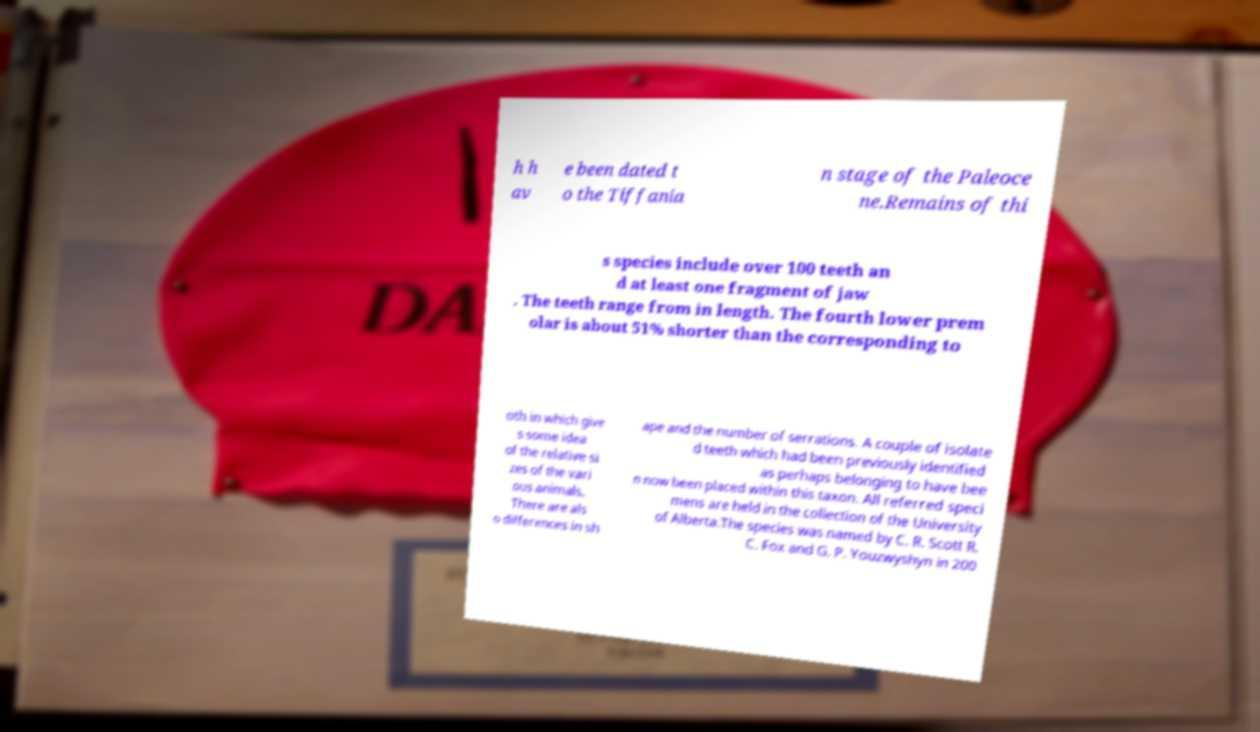There's text embedded in this image that I need extracted. Can you transcribe it verbatim? h h av e been dated t o the Tiffania n stage of the Paleoce ne.Remains of thi s species include over 100 teeth an d at least one fragment of jaw . The teeth range from in length. The fourth lower prem olar is about 51% shorter than the corresponding to oth in which give s some idea of the relative si zes of the vari ous animals. There are als o differences in sh ape and the number of serrations. A couple of isolate d teeth which had been previously identified as perhaps belonging to have bee n now been placed within this taxon. All referred speci mens are held in the collection of the University of Alberta.The species was named by C. R. Scott R. C. Fox and G. P. Youzwyshyn in 200 